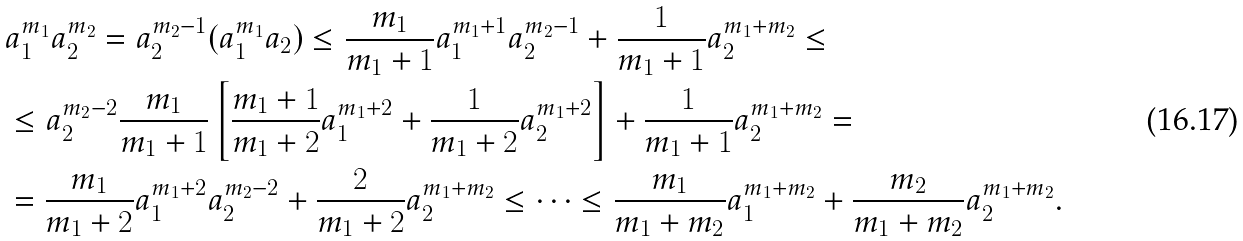Convert formula to latex. <formula><loc_0><loc_0><loc_500><loc_500>& a _ { 1 } ^ { m _ { 1 } } a _ { 2 } ^ { m _ { 2 } } = a _ { 2 } ^ { m _ { 2 } - 1 } ( a _ { 1 } ^ { m _ { 1 } } a _ { 2 } ) \leq \frac { m _ { 1 } } { m _ { 1 } + 1 } a _ { 1 } ^ { m _ { 1 } + 1 } a _ { 2 } ^ { m _ { 2 } - 1 } + \frac { 1 } { m _ { 1 } + 1 } a _ { 2 } ^ { m _ { 1 } + m _ { 2 } } \leq \\ & \leq a _ { 2 } ^ { m _ { 2 } - 2 } \frac { m _ { 1 } } { m _ { 1 } + 1 } \left [ \frac { m _ { 1 } + 1 } { m _ { 1 } + 2 } a _ { 1 } ^ { m _ { 1 } + 2 } + \frac { 1 } { m _ { 1 } + 2 } a _ { 2 } ^ { m _ { 1 } + 2 } \right ] + \frac { 1 } { m _ { 1 } + 1 } a _ { 2 } ^ { m _ { 1 } + m _ { 2 } } = \\ & = \frac { m _ { 1 } } { m _ { 1 } + 2 } a _ { 1 } ^ { m _ { 1 } + 2 } a _ { 2 } ^ { m _ { 2 } - 2 } + \frac { 2 } { m _ { 1 } + 2 } a _ { 2 } ^ { m _ { 1 } + m _ { 2 } } \leq \dots \leq \frac { m _ { 1 } } { m _ { 1 } + m _ { 2 } } a _ { 1 } ^ { m _ { 1 } + m _ { 2 } } + \frac { m _ { 2 } } { m _ { 1 } + m _ { 2 } } a _ { 2 } ^ { m _ { 1 } + m _ { 2 } } .</formula> 